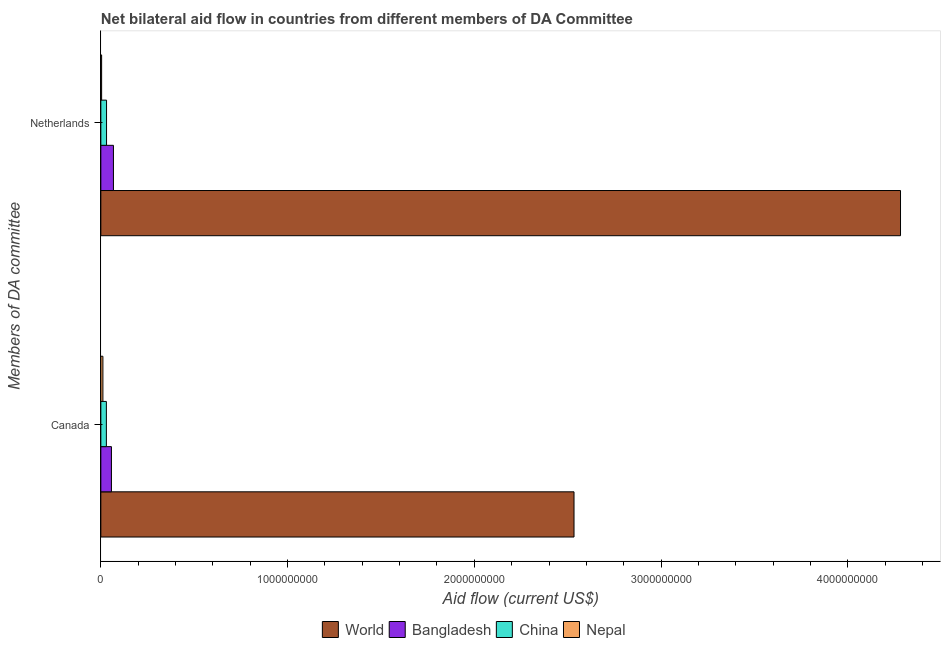How many different coloured bars are there?
Ensure brevity in your answer.  4. How many groups of bars are there?
Ensure brevity in your answer.  2. Are the number of bars per tick equal to the number of legend labels?
Provide a short and direct response. Yes. What is the amount of aid given by netherlands in Bangladesh?
Your answer should be very brief. 6.74e+07. Across all countries, what is the maximum amount of aid given by canada?
Provide a succinct answer. 2.53e+09. Across all countries, what is the minimum amount of aid given by canada?
Provide a short and direct response. 1.11e+07. In which country was the amount of aid given by netherlands maximum?
Offer a very short reply. World. In which country was the amount of aid given by canada minimum?
Offer a terse response. Nepal. What is the total amount of aid given by netherlands in the graph?
Keep it short and to the point. 4.38e+09. What is the difference between the amount of aid given by canada in China and that in World?
Make the answer very short. -2.50e+09. What is the difference between the amount of aid given by netherlands in Bangladesh and the amount of aid given by canada in China?
Give a very brief answer. 3.78e+07. What is the average amount of aid given by canada per country?
Offer a very short reply. 6.58e+08. What is the difference between the amount of aid given by netherlands and amount of aid given by canada in Bangladesh?
Make the answer very short. 1.07e+07. In how many countries, is the amount of aid given by netherlands greater than 1000000000 US$?
Provide a short and direct response. 1. What is the ratio of the amount of aid given by canada in Nepal to that in China?
Keep it short and to the point. 0.37. In how many countries, is the amount of aid given by netherlands greater than the average amount of aid given by netherlands taken over all countries?
Provide a succinct answer. 1. How many bars are there?
Offer a very short reply. 8. What is the difference between two consecutive major ticks on the X-axis?
Your answer should be very brief. 1.00e+09. Are the values on the major ticks of X-axis written in scientific E-notation?
Keep it short and to the point. No. How are the legend labels stacked?
Offer a very short reply. Horizontal. What is the title of the graph?
Offer a very short reply. Net bilateral aid flow in countries from different members of DA Committee. Does "Turkmenistan" appear as one of the legend labels in the graph?
Provide a short and direct response. No. What is the label or title of the X-axis?
Make the answer very short. Aid flow (current US$). What is the label or title of the Y-axis?
Give a very brief answer. Members of DA committee. What is the Aid flow (current US$) of World in Canada?
Ensure brevity in your answer.  2.53e+09. What is the Aid flow (current US$) in Bangladesh in Canada?
Your answer should be compact. 5.67e+07. What is the Aid flow (current US$) in China in Canada?
Your answer should be compact. 2.96e+07. What is the Aid flow (current US$) of Nepal in Canada?
Provide a succinct answer. 1.11e+07. What is the Aid flow (current US$) of World in Netherlands?
Offer a very short reply. 4.28e+09. What is the Aid flow (current US$) of Bangladesh in Netherlands?
Make the answer very short. 6.74e+07. What is the Aid flow (current US$) of China in Netherlands?
Offer a very short reply. 3.05e+07. What is the Aid flow (current US$) of Nepal in Netherlands?
Ensure brevity in your answer.  4.20e+06. Across all Members of DA committee, what is the maximum Aid flow (current US$) of World?
Offer a terse response. 4.28e+09. Across all Members of DA committee, what is the maximum Aid flow (current US$) of Bangladesh?
Offer a terse response. 6.74e+07. Across all Members of DA committee, what is the maximum Aid flow (current US$) in China?
Make the answer very short. 3.05e+07. Across all Members of DA committee, what is the maximum Aid flow (current US$) in Nepal?
Offer a terse response. 1.11e+07. Across all Members of DA committee, what is the minimum Aid flow (current US$) of World?
Provide a succinct answer. 2.53e+09. Across all Members of DA committee, what is the minimum Aid flow (current US$) in Bangladesh?
Your answer should be compact. 5.67e+07. Across all Members of DA committee, what is the minimum Aid flow (current US$) in China?
Your answer should be compact. 2.96e+07. Across all Members of DA committee, what is the minimum Aid flow (current US$) in Nepal?
Provide a succinct answer. 4.20e+06. What is the total Aid flow (current US$) of World in the graph?
Ensure brevity in your answer.  6.82e+09. What is the total Aid flow (current US$) of Bangladesh in the graph?
Give a very brief answer. 1.24e+08. What is the total Aid flow (current US$) in China in the graph?
Your answer should be compact. 6.01e+07. What is the total Aid flow (current US$) in Nepal in the graph?
Your response must be concise. 1.53e+07. What is the difference between the Aid flow (current US$) of World in Canada and that in Netherlands?
Offer a terse response. -1.75e+09. What is the difference between the Aid flow (current US$) in Bangladesh in Canada and that in Netherlands?
Keep it short and to the point. -1.07e+07. What is the difference between the Aid flow (current US$) in China in Canada and that in Netherlands?
Keep it short and to the point. -9.10e+05. What is the difference between the Aid flow (current US$) in Nepal in Canada and that in Netherlands?
Provide a short and direct response. 6.87e+06. What is the difference between the Aid flow (current US$) of World in Canada and the Aid flow (current US$) of Bangladesh in Netherlands?
Keep it short and to the point. 2.47e+09. What is the difference between the Aid flow (current US$) of World in Canada and the Aid flow (current US$) of China in Netherlands?
Keep it short and to the point. 2.50e+09. What is the difference between the Aid flow (current US$) in World in Canada and the Aid flow (current US$) in Nepal in Netherlands?
Give a very brief answer. 2.53e+09. What is the difference between the Aid flow (current US$) of Bangladesh in Canada and the Aid flow (current US$) of China in Netherlands?
Give a very brief answer. 2.62e+07. What is the difference between the Aid flow (current US$) of Bangladesh in Canada and the Aid flow (current US$) of Nepal in Netherlands?
Keep it short and to the point. 5.25e+07. What is the difference between the Aid flow (current US$) in China in Canada and the Aid flow (current US$) in Nepal in Netherlands?
Give a very brief answer. 2.54e+07. What is the average Aid flow (current US$) of World per Members of DA committee?
Keep it short and to the point. 3.41e+09. What is the average Aid flow (current US$) in Bangladesh per Members of DA committee?
Make the answer very short. 6.21e+07. What is the average Aid flow (current US$) of China per Members of DA committee?
Offer a terse response. 3.01e+07. What is the average Aid flow (current US$) of Nepal per Members of DA committee?
Provide a succinct answer. 7.64e+06. What is the difference between the Aid flow (current US$) of World and Aid flow (current US$) of Bangladesh in Canada?
Provide a succinct answer. 2.48e+09. What is the difference between the Aid flow (current US$) in World and Aid flow (current US$) in China in Canada?
Provide a short and direct response. 2.50e+09. What is the difference between the Aid flow (current US$) of World and Aid flow (current US$) of Nepal in Canada?
Your response must be concise. 2.52e+09. What is the difference between the Aid flow (current US$) in Bangladesh and Aid flow (current US$) in China in Canada?
Your answer should be very brief. 2.71e+07. What is the difference between the Aid flow (current US$) in Bangladesh and Aid flow (current US$) in Nepal in Canada?
Give a very brief answer. 4.57e+07. What is the difference between the Aid flow (current US$) of China and Aid flow (current US$) of Nepal in Canada?
Your response must be concise. 1.85e+07. What is the difference between the Aid flow (current US$) in World and Aid flow (current US$) in Bangladesh in Netherlands?
Offer a very short reply. 4.21e+09. What is the difference between the Aid flow (current US$) of World and Aid flow (current US$) of China in Netherlands?
Ensure brevity in your answer.  4.25e+09. What is the difference between the Aid flow (current US$) in World and Aid flow (current US$) in Nepal in Netherlands?
Your answer should be compact. 4.28e+09. What is the difference between the Aid flow (current US$) of Bangladesh and Aid flow (current US$) of China in Netherlands?
Offer a very short reply. 3.69e+07. What is the difference between the Aid flow (current US$) in Bangladesh and Aid flow (current US$) in Nepal in Netherlands?
Your answer should be compact. 6.32e+07. What is the difference between the Aid flow (current US$) in China and Aid flow (current US$) in Nepal in Netherlands?
Give a very brief answer. 2.63e+07. What is the ratio of the Aid flow (current US$) in World in Canada to that in Netherlands?
Make the answer very short. 0.59. What is the ratio of the Aid flow (current US$) in Bangladesh in Canada to that in Netherlands?
Provide a succinct answer. 0.84. What is the ratio of the Aid flow (current US$) in China in Canada to that in Netherlands?
Provide a succinct answer. 0.97. What is the ratio of the Aid flow (current US$) in Nepal in Canada to that in Netherlands?
Your response must be concise. 2.64. What is the difference between the highest and the second highest Aid flow (current US$) in World?
Give a very brief answer. 1.75e+09. What is the difference between the highest and the second highest Aid flow (current US$) in Bangladesh?
Keep it short and to the point. 1.07e+07. What is the difference between the highest and the second highest Aid flow (current US$) in China?
Make the answer very short. 9.10e+05. What is the difference between the highest and the second highest Aid flow (current US$) of Nepal?
Your answer should be very brief. 6.87e+06. What is the difference between the highest and the lowest Aid flow (current US$) of World?
Give a very brief answer. 1.75e+09. What is the difference between the highest and the lowest Aid flow (current US$) in Bangladesh?
Your response must be concise. 1.07e+07. What is the difference between the highest and the lowest Aid flow (current US$) of China?
Provide a short and direct response. 9.10e+05. What is the difference between the highest and the lowest Aid flow (current US$) in Nepal?
Your answer should be very brief. 6.87e+06. 